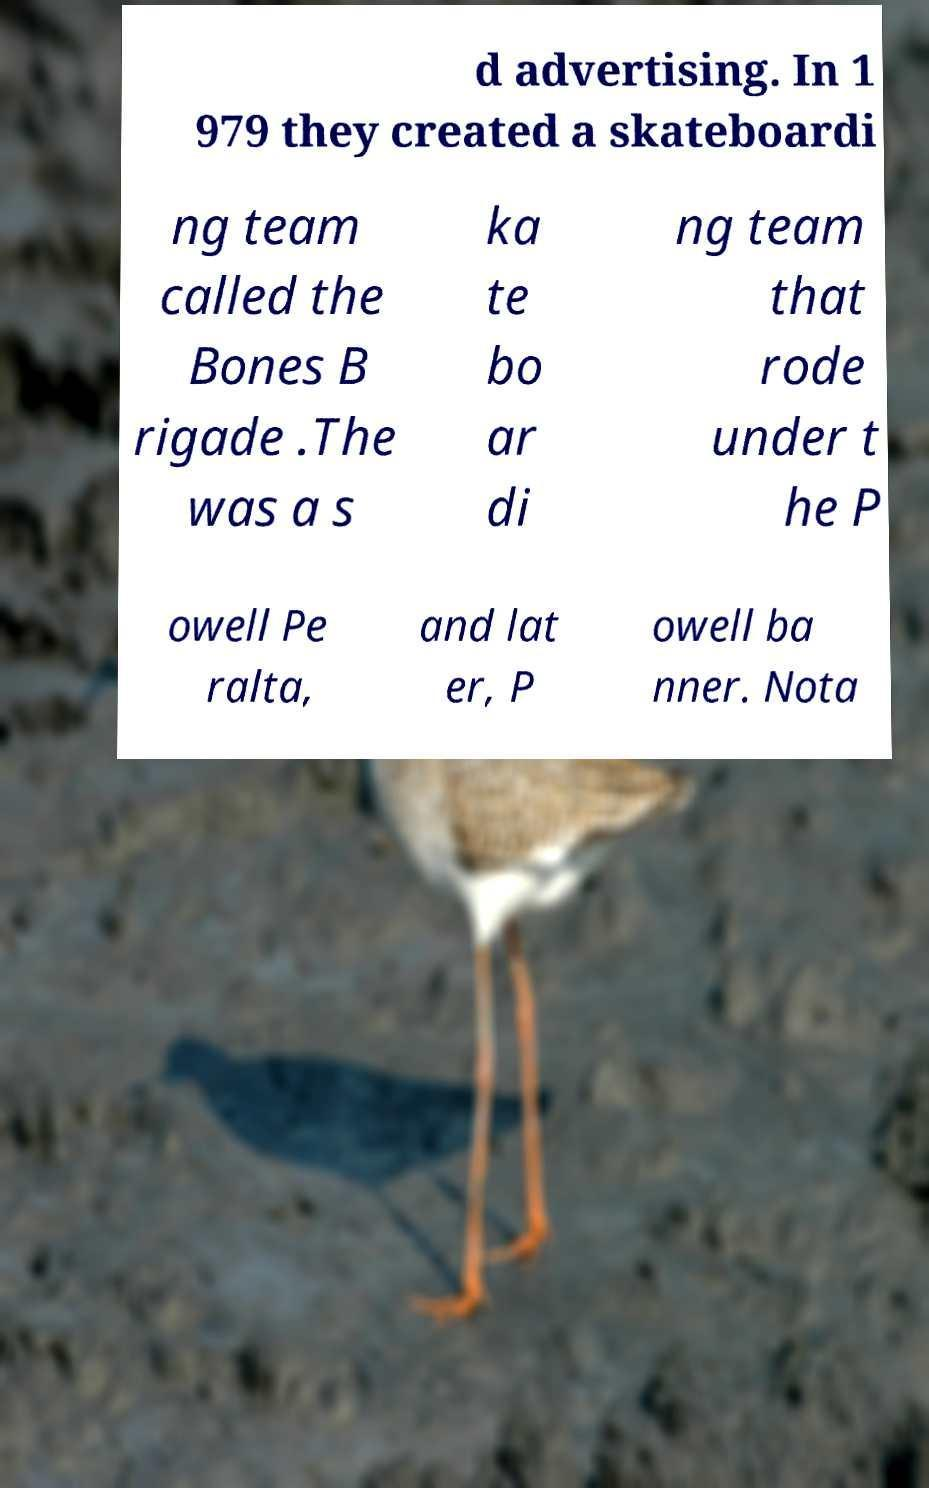Can you accurately transcribe the text from the provided image for me? d advertising. In 1 979 they created a skateboardi ng team called the Bones B rigade .The was a s ka te bo ar di ng team that rode under t he P owell Pe ralta, and lat er, P owell ba nner. Nota 